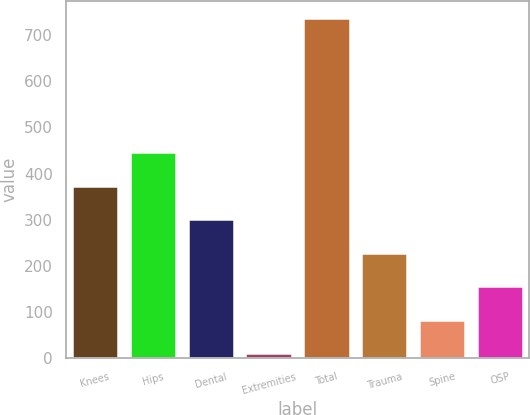Convert chart to OTSL. <chart><loc_0><loc_0><loc_500><loc_500><bar_chart><fcel>Knees<fcel>Hips<fcel>Dental<fcel>Extremities<fcel>Total<fcel>Trauma<fcel>Spine<fcel>OSP<nl><fcel>374.2<fcel>446.72<fcel>301.68<fcel>11.6<fcel>736.8<fcel>229.16<fcel>84.12<fcel>156.64<nl></chart> 